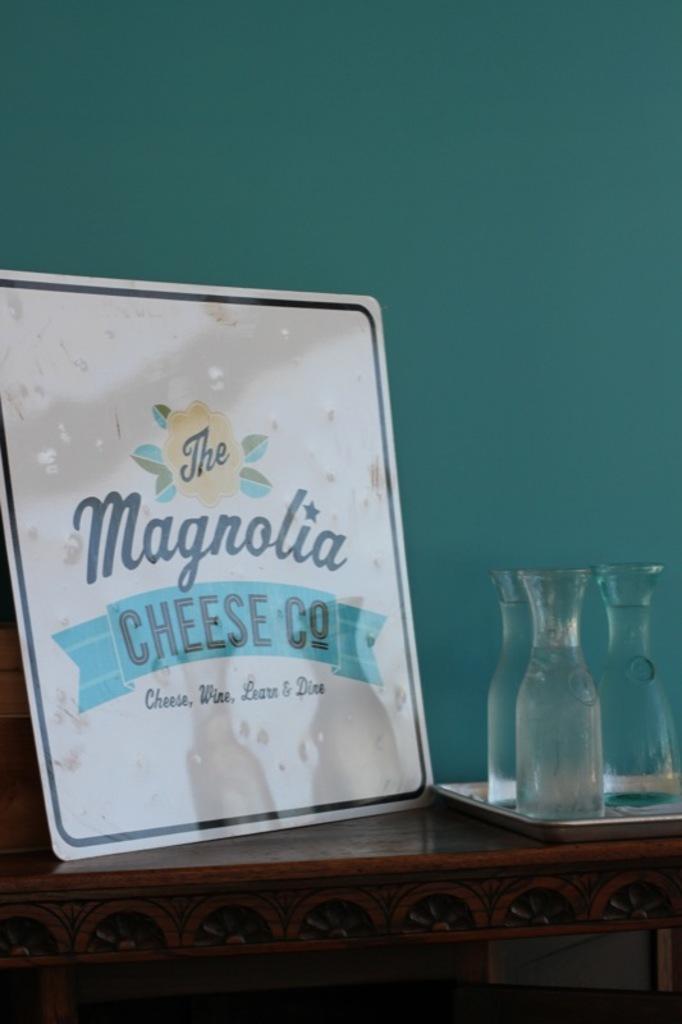In one or two sentences, can you explain what this image depicts? In this image in the front there is a table, on the table there is a board with some text written on it and there are glasses. 